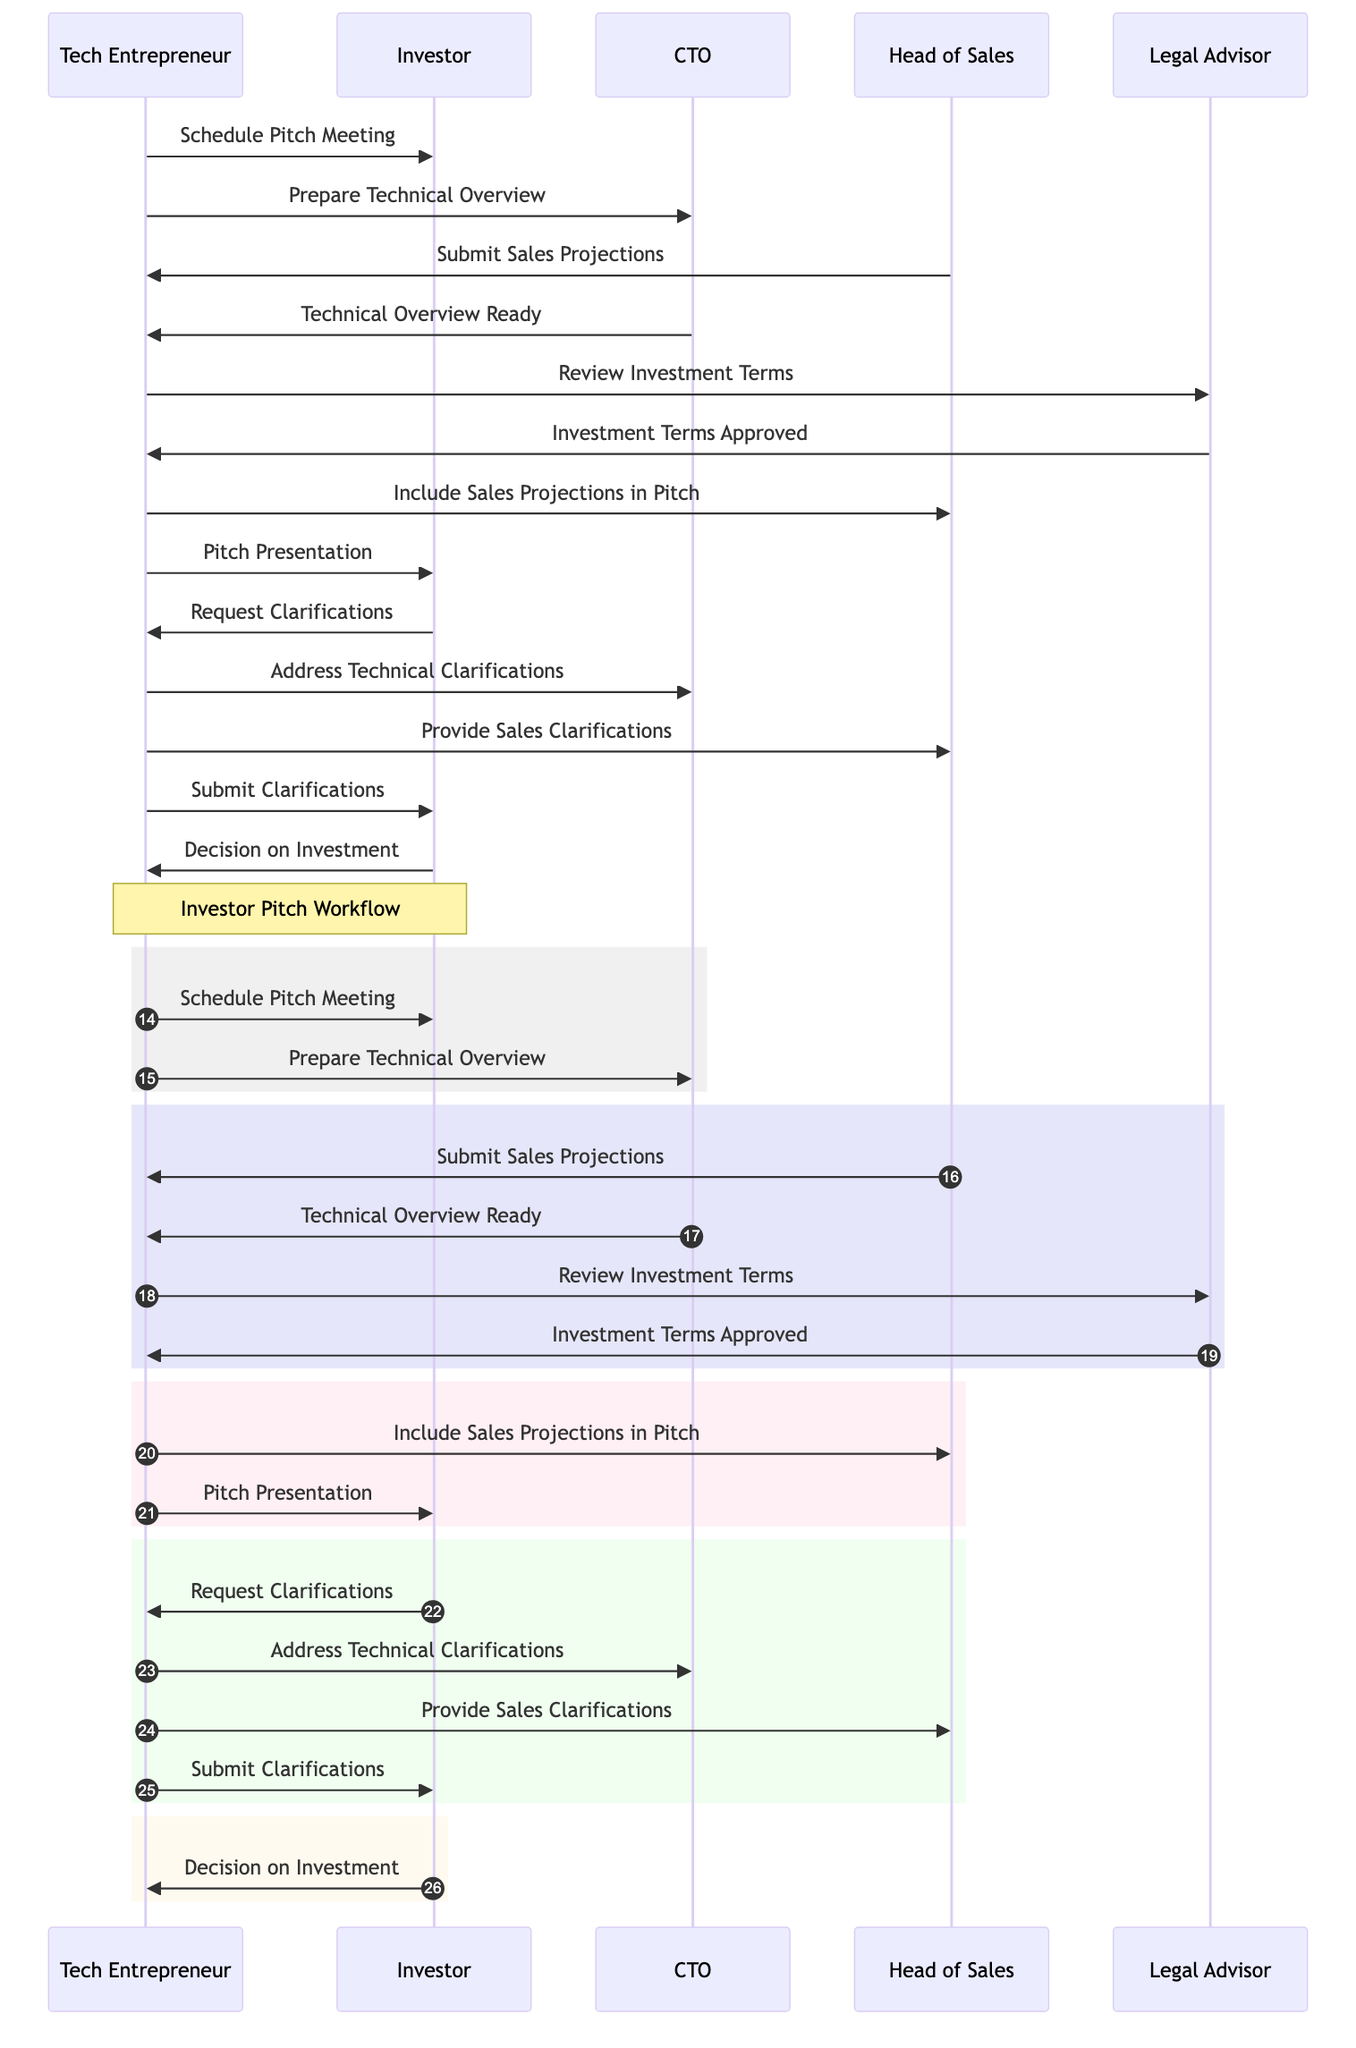What is the first action taken by the Tech Entrepreneur? The first action shown in the diagram is "Schedule Pitch Meeting" from the Tech Entrepreneur to the Investor. It appears as the initial message in the sequence.
Answer: Schedule Pitch Meeting How many participants are involved in the workflow? The diagram has five distinct participants: Tech Entrepreneur, Investor, CTO, Head of Sales, and Legal Advisor. Each of these is represented as a node in the sequence diagram.
Answer: Five What message does the Head of Sales send to the Tech Entrepreneur? The Head of Sales sends "Submit Sales Projections" to the Tech Entrepreneur, which is reflected in the corresponding message in the diagram.
Answer: Submit Sales Projections Which participant reviews the investment terms? The Legal Advisor is the participant who reviews the investment terms as indicated by the message "Review Investment Terms" from the Tech Entrepreneur to the Legal Advisor.
Answer: Legal Advisor What message does the Investor send after the pitch presentation? After the pitch presentation, the Investor sends "Request Clarifications" to the Tech Entrepreneur, following the step of the pitch presentation in the sequence.
Answer: Request Clarifications What happens after the Technical Overview is ready? Once the Technical Overview is ready, the CTO sends "Technical Overview Ready" back to the Tech Entrepreneur, indicating that the requested preparation has been completed.
Answer: Technical Overview Ready What is the last message sent in the diagram? The last message in the diagram is "Decision on Investment," which is sent from the Investor to the Tech Entrepreneur, concluding the sequence flow.
Answer: Decision on Investment Which two participants are involved in the review of the investment terms? The two participants involved in the review of the investment terms are the Tech Entrepreneur and the Legal Advisor. The Tech Entrepreneur initiates the review and awaits approval from the Legal Advisor.
Answer: Tech Entrepreneur and Legal Advisor During which part of the sequence does the Tech Entrepreneur include sales projections in the pitch? The Tech Entrepreneur includes sales projections in the pitch after receiving "Submit Sales Projections" from the Head of Sales and before the "Pitch Presentation" message. This indicates it occurs in that workflow segment.
Answer: Before the Pitch Presentation 